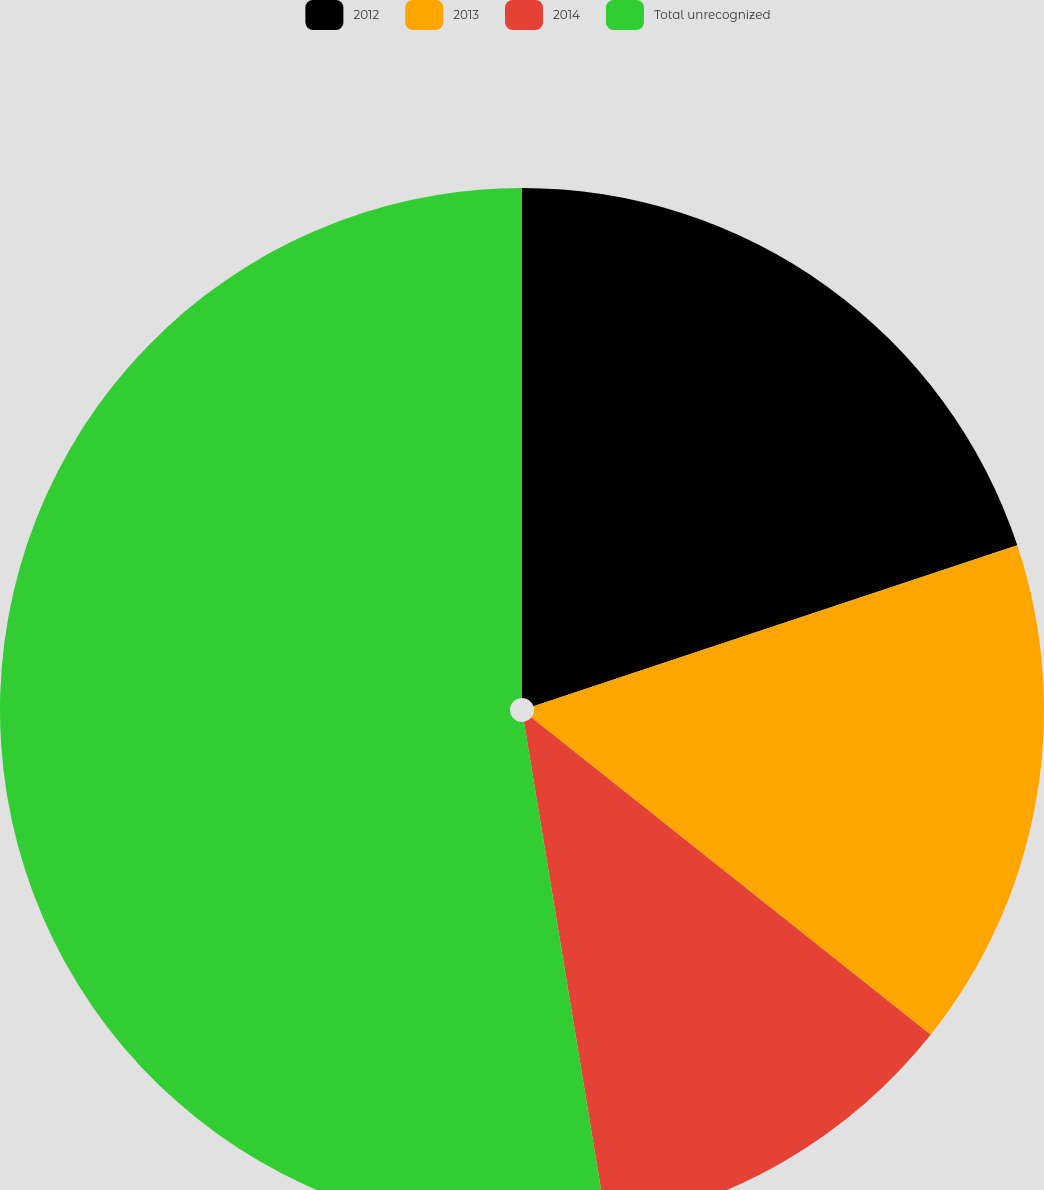<chart> <loc_0><loc_0><loc_500><loc_500><pie_chart><fcel>2012<fcel>2013<fcel>2014<fcel>Total unrecognized<nl><fcel>19.89%<fcel>15.8%<fcel>11.71%<fcel>52.6%<nl></chart> 